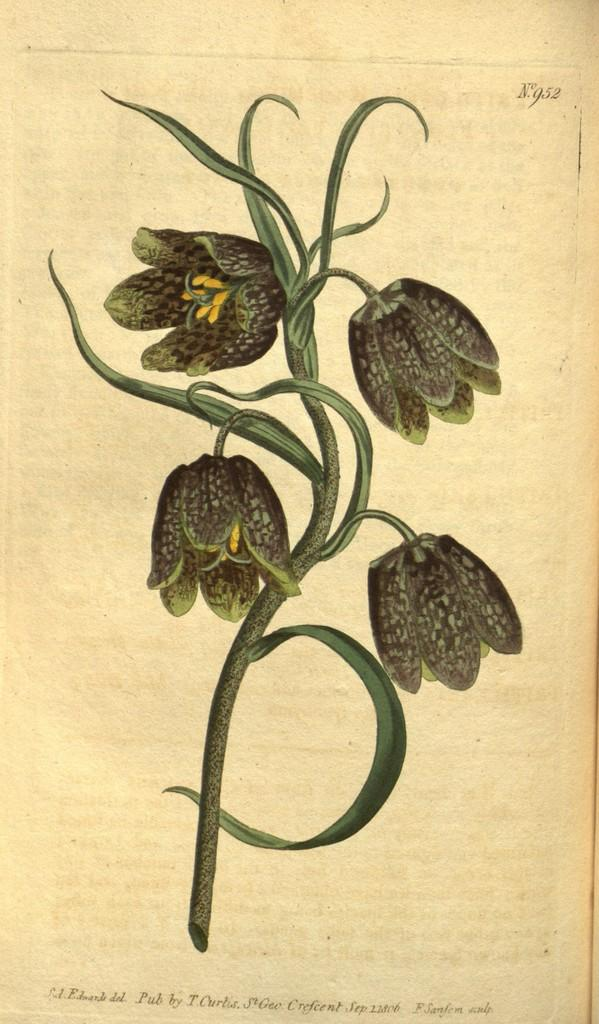What is the main subject of the image? The image contains a page from a book. What type of illustration is present on the page? There is a picture of flowers and stems on the page. Is there any text on the page? Yes, there is text on the page. How many pies are visible in the image? There are no pies present in the image; it features a page from a book with a picture of flowers and stems, along with text. 